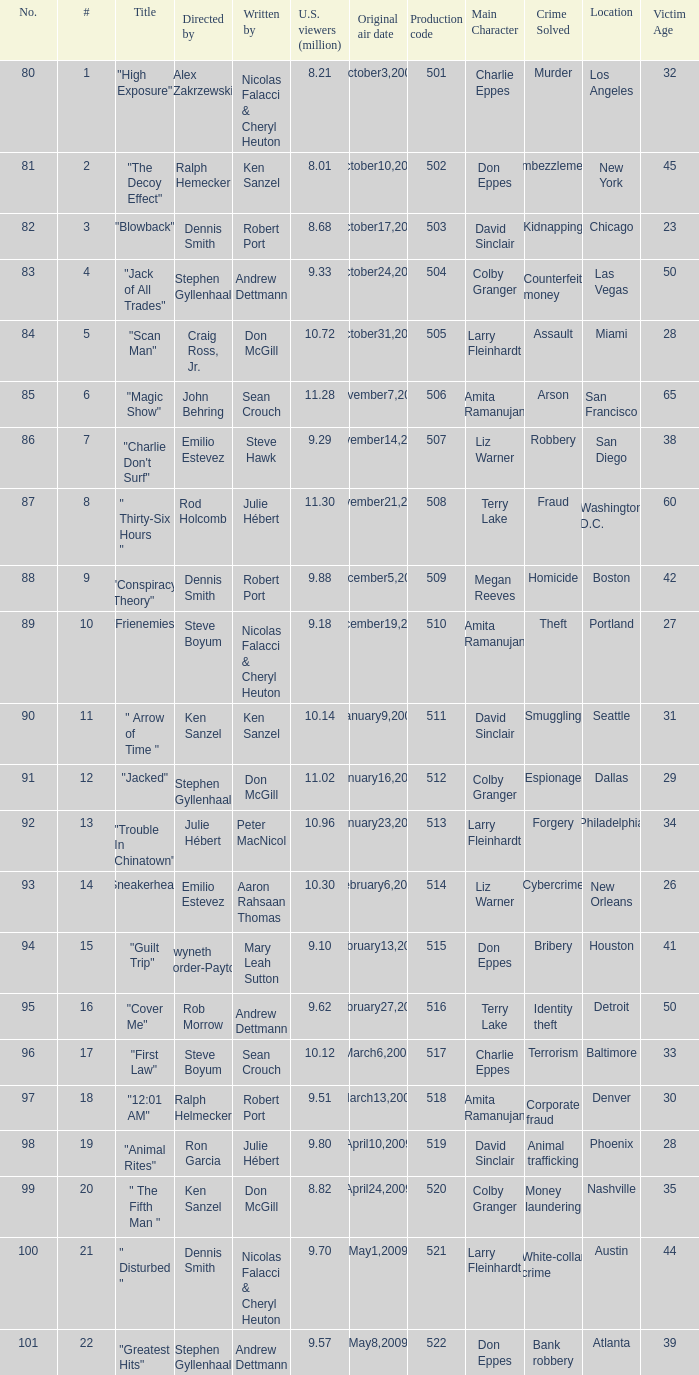14 million viewers (u.s.)? 11.0. 